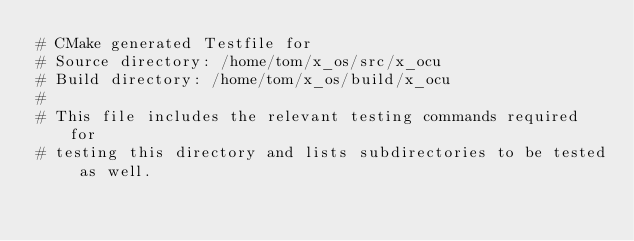Convert code to text. <code><loc_0><loc_0><loc_500><loc_500><_CMake_># CMake generated Testfile for 
# Source directory: /home/tom/x_os/src/x_ocu
# Build directory: /home/tom/x_os/build/x_ocu
# 
# This file includes the relevant testing commands required for 
# testing this directory and lists subdirectories to be tested as well.
</code> 